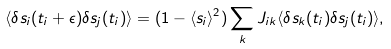Convert formula to latex. <formula><loc_0><loc_0><loc_500><loc_500>\langle \delta s _ { i } ( t _ { i } + \epsilon ) \delta s _ { j } ( t _ { i } ) \rangle = ( 1 - \langle s _ { i } \rangle ^ { 2 } ) \sum _ { k } J _ { i k } \langle \delta s _ { k } ( t _ { i } ) \delta s _ { j } ( t _ { i } ) \rangle ,</formula> 